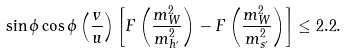<formula> <loc_0><loc_0><loc_500><loc_500>\sin \phi \cos \phi \left ( \frac { v } { u } \right ) \left [ F \left ( \frac { m ^ { 2 } _ { W } } { m ^ { 2 } _ { h ^ { \prime } } } \right ) - F \left ( \frac { m ^ { 2 } _ { W } } { m ^ { 2 } _ { s ^ { \prime } } } \right ) \right ] \leq 2 . 2 .</formula> 